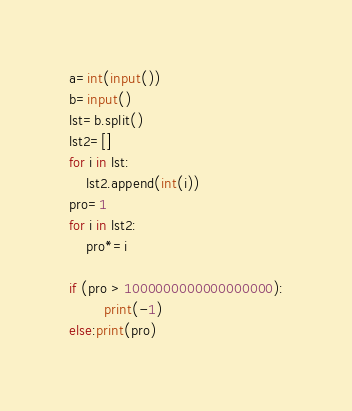<code> <loc_0><loc_0><loc_500><loc_500><_Python_>a=int(input())
b=input()
lst=b.split()
lst2=[]
for i in lst:
    lst2.append(int(i))
pro=1
for i in lst2:
    pro*=i
    
if (pro > 1000000000000000000):
        print(-1)
else:print(pro)</code> 